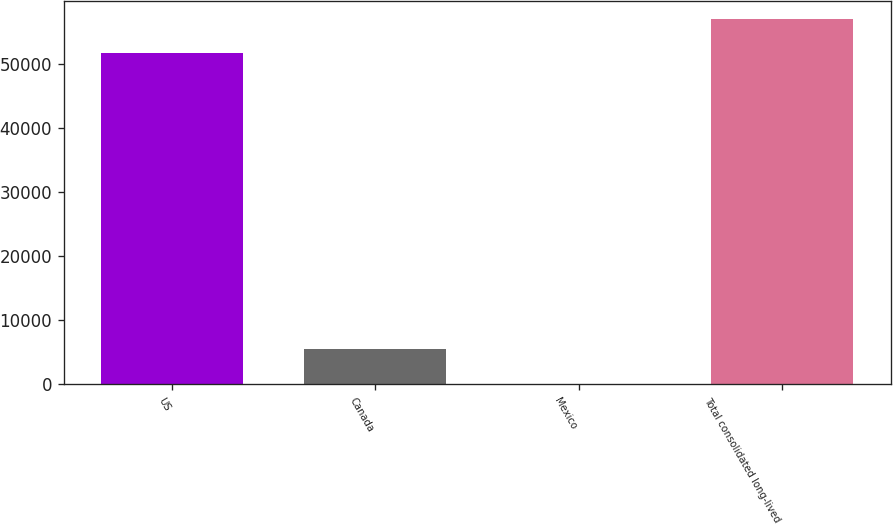<chart> <loc_0><loc_0><loc_500><loc_500><bar_chart><fcel>US<fcel>Canada<fcel>Mexico<fcel>Total consolidated long-lived<nl><fcel>51679<fcel>5454.2<fcel>67<fcel>57066.2<nl></chart> 